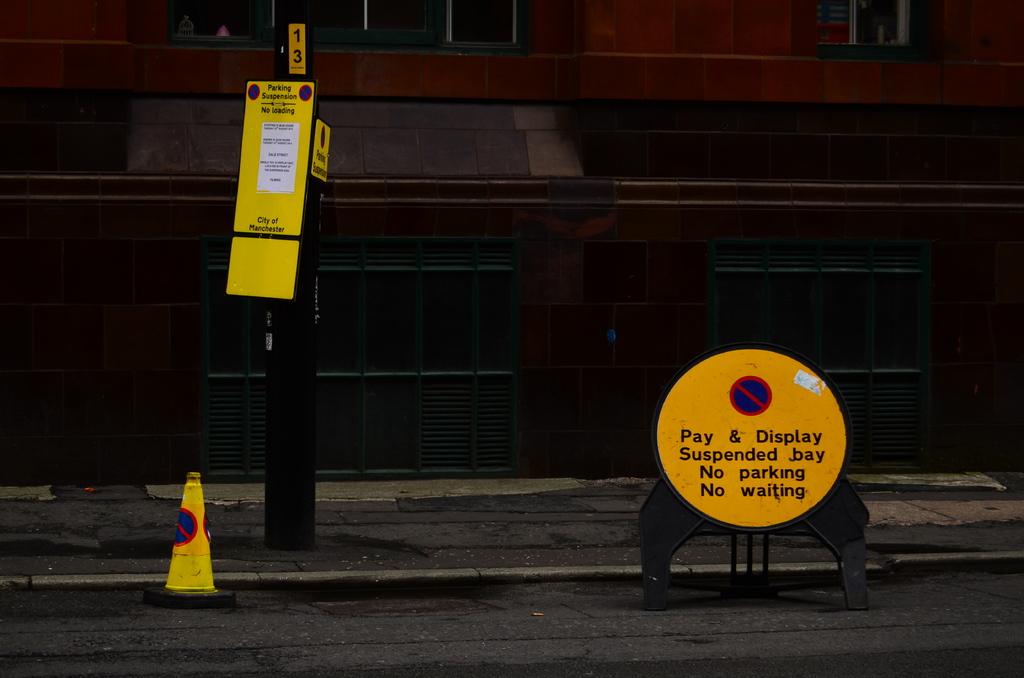What is suspended according to the sign?
Give a very brief answer. Pay and display. 